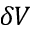<formula> <loc_0><loc_0><loc_500><loc_500>\delta V</formula> 